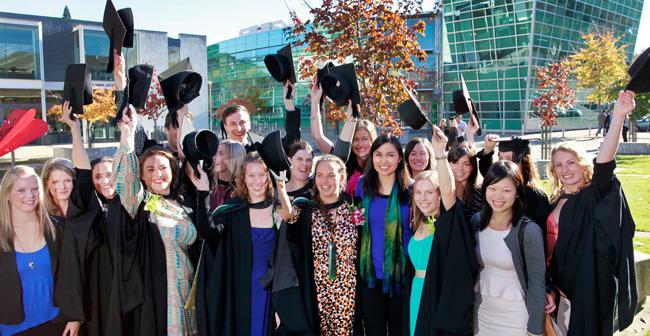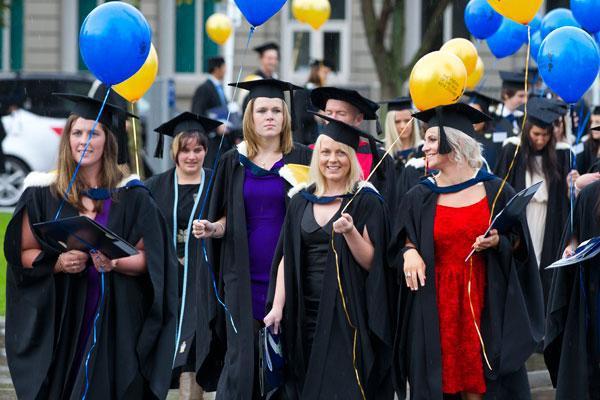The first image is the image on the left, the second image is the image on the right. Evaluate the accuracy of this statement regarding the images: "The right image features graduates in black robes and caps, with blue and yellow balloons in the air.". Is it true? Answer yes or no. Yes. The first image is the image on the left, the second image is the image on the right. Examine the images to the left and right. Is the description "Several people stand in a single line outside in the grass in the image on the right." accurate? Answer yes or no. No. 